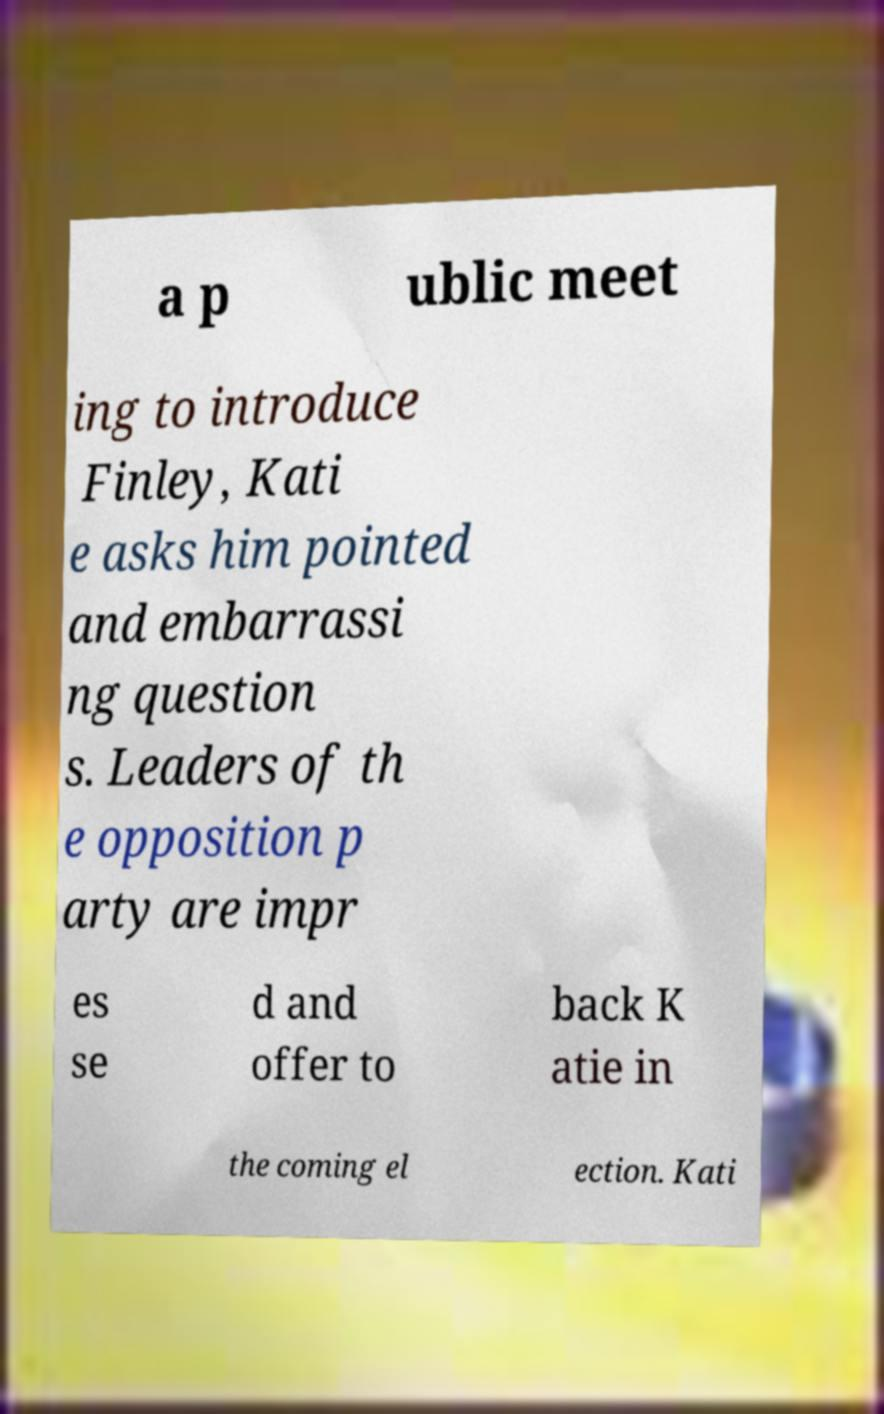Please read and relay the text visible in this image. What does it say? a p ublic meet ing to introduce Finley, Kati e asks him pointed and embarrassi ng question s. Leaders of th e opposition p arty are impr es se d and offer to back K atie in the coming el ection. Kati 